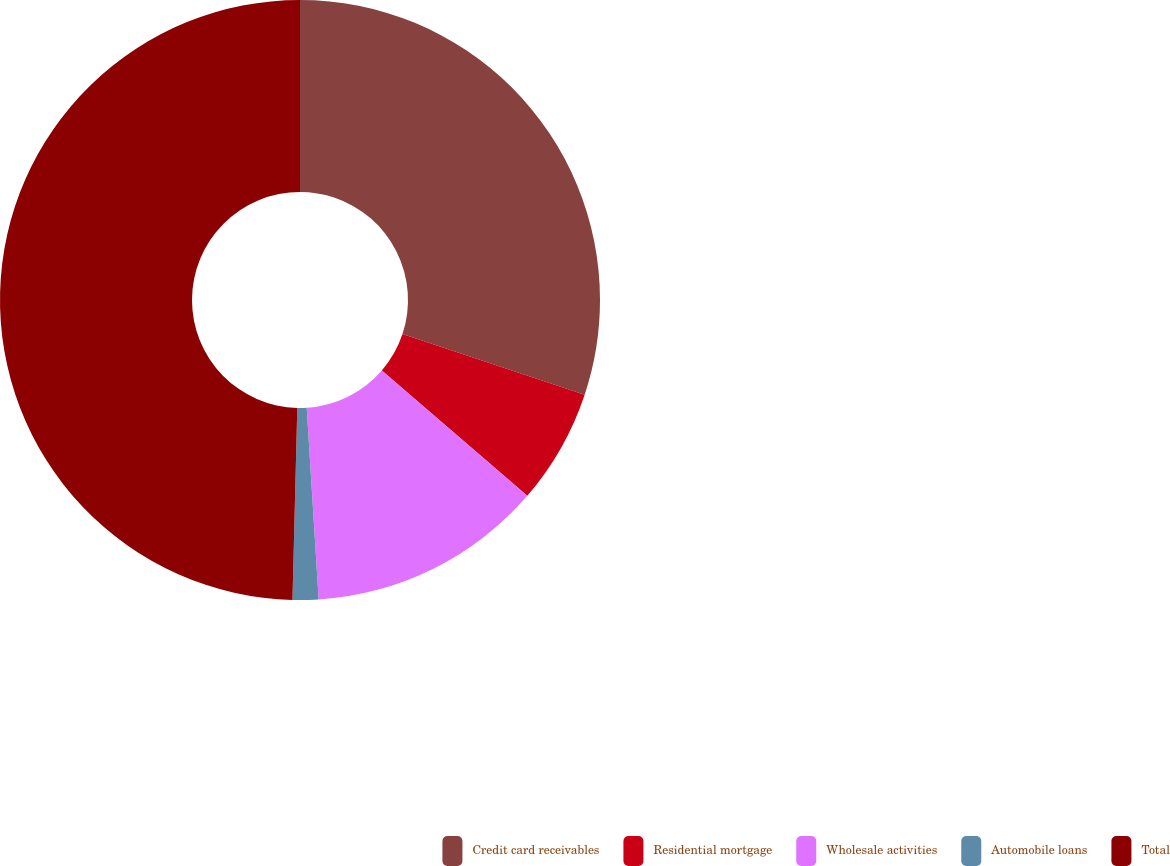Convert chart. <chart><loc_0><loc_0><loc_500><loc_500><pie_chart><fcel>Credit card receivables<fcel>Residential mortgage<fcel>Wholesale activities<fcel>Automobile loans<fcel>Total<nl><fcel>30.11%<fcel>6.21%<fcel>12.69%<fcel>1.39%<fcel>49.6%<nl></chart> 